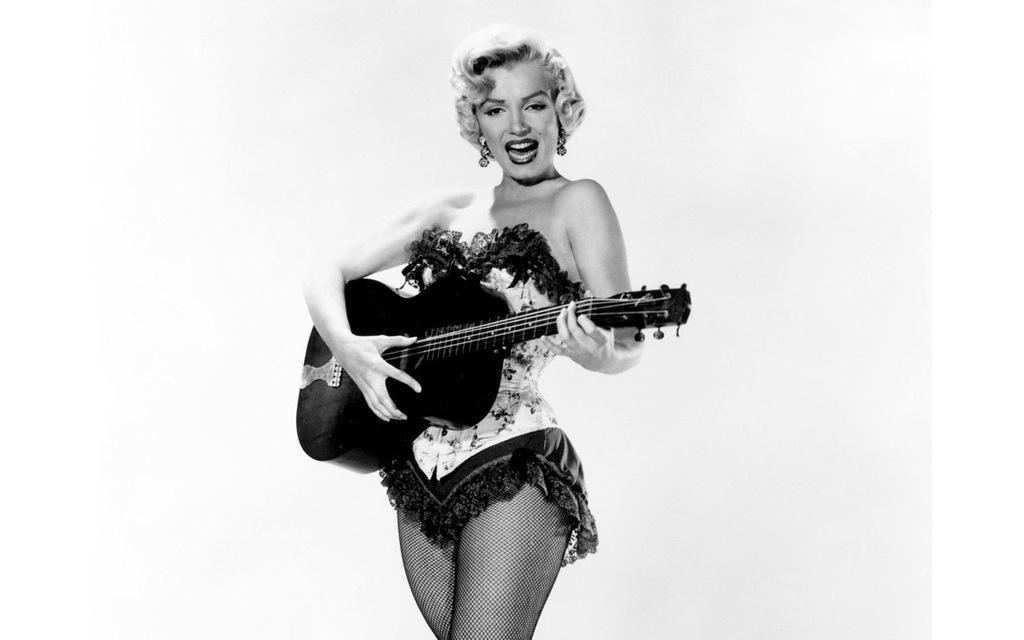Describe this image in one or two sentences. In this image there is a lady who is standing at the center of the image by holding a guitar in her hand and the area of the background is white in color. 